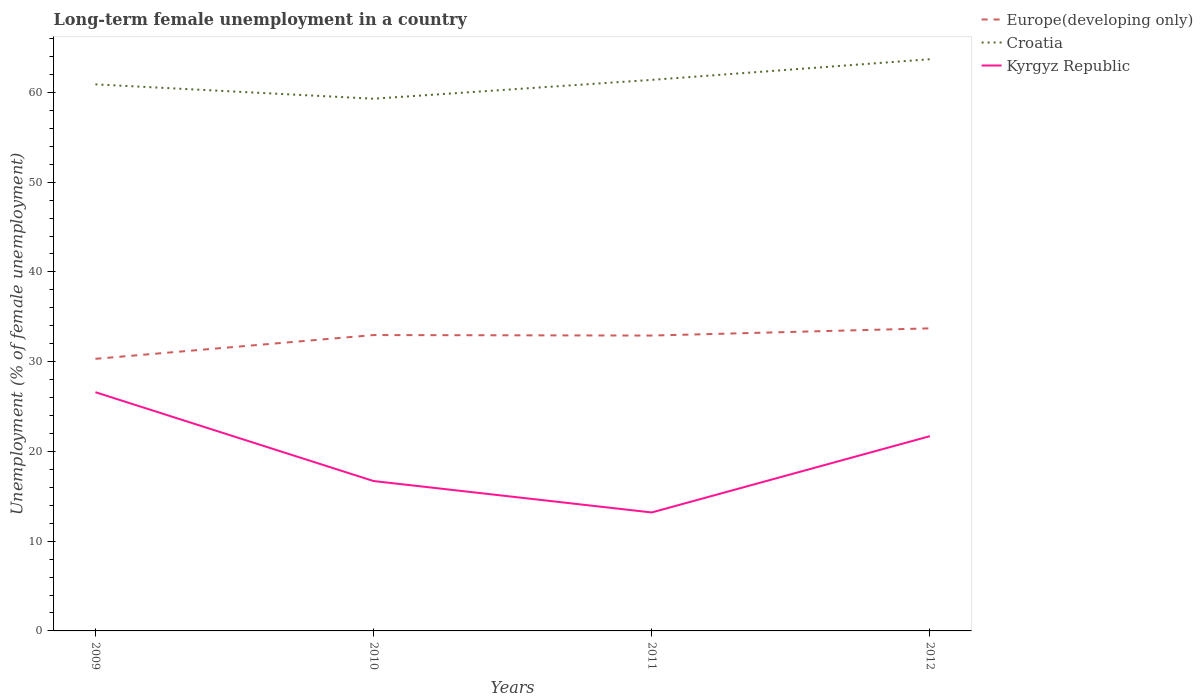Across all years, what is the maximum percentage of long-term unemployed female population in Croatia?
Your answer should be compact. 59.3. In which year was the percentage of long-term unemployed female population in Croatia maximum?
Your answer should be compact. 2010. What is the total percentage of long-term unemployed female population in Croatia in the graph?
Your answer should be compact. -2.3. What is the difference between the highest and the second highest percentage of long-term unemployed female population in Croatia?
Keep it short and to the point. 4.4. How many lines are there?
Ensure brevity in your answer.  3. How many years are there in the graph?
Make the answer very short. 4. What is the difference between two consecutive major ticks on the Y-axis?
Offer a terse response. 10. Are the values on the major ticks of Y-axis written in scientific E-notation?
Provide a short and direct response. No. Does the graph contain any zero values?
Offer a terse response. No. Does the graph contain grids?
Provide a succinct answer. No. What is the title of the graph?
Your response must be concise. Long-term female unemployment in a country. Does "Georgia" appear as one of the legend labels in the graph?
Provide a succinct answer. No. What is the label or title of the Y-axis?
Provide a short and direct response. Unemployment (% of female unemployment). What is the Unemployment (% of female unemployment) of Europe(developing only) in 2009?
Offer a very short reply. 30.32. What is the Unemployment (% of female unemployment) of Croatia in 2009?
Offer a terse response. 60.9. What is the Unemployment (% of female unemployment) in Kyrgyz Republic in 2009?
Offer a terse response. 26.6. What is the Unemployment (% of female unemployment) in Europe(developing only) in 2010?
Offer a terse response. 32.97. What is the Unemployment (% of female unemployment) of Croatia in 2010?
Keep it short and to the point. 59.3. What is the Unemployment (% of female unemployment) in Kyrgyz Republic in 2010?
Make the answer very short. 16.7. What is the Unemployment (% of female unemployment) of Europe(developing only) in 2011?
Offer a terse response. 32.91. What is the Unemployment (% of female unemployment) in Croatia in 2011?
Ensure brevity in your answer.  61.4. What is the Unemployment (% of female unemployment) of Kyrgyz Republic in 2011?
Keep it short and to the point. 13.2. What is the Unemployment (% of female unemployment) in Europe(developing only) in 2012?
Your response must be concise. 33.71. What is the Unemployment (% of female unemployment) of Croatia in 2012?
Provide a succinct answer. 63.7. What is the Unemployment (% of female unemployment) of Kyrgyz Republic in 2012?
Give a very brief answer. 21.7. Across all years, what is the maximum Unemployment (% of female unemployment) in Europe(developing only)?
Your response must be concise. 33.71. Across all years, what is the maximum Unemployment (% of female unemployment) of Croatia?
Your answer should be very brief. 63.7. Across all years, what is the maximum Unemployment (% of female unemployment) of Kyrgyz Republic?
Your response must be concise. 26.6. Across all years, what is the minimum Unemployment (% of female unemployment) of Europe(developing only)?
Your response must be concise. 30.32. Across all years, what is the minimum Unemployment (% of female unemployment) of Croatia?
Offer a very short reply. 59.3. Across all years, what is the minimum Unemployment (% of female unemployment) in Kyrgyz Republic?
Provide a succinct answer. 13.2. What is the total Unemployment (% of female unemployment) of Europe(developing only) in the graph?
Ensure brevity in your answer.  129.91. What is the total Unemployment (% of female unemployment) in Croatia in the graph?
Ensure brevity in your answer.  245.3. What is the total Unemployment (% of female unemployment) of Kyrgyz Republic in the graph?
Provide a short and direct response. 78.2. What is the difference between the Unemployment (% of female unemployment) in Europe(developing only) in 2009 and that in 2010?
Make the answer very short. -2.65. What is the difference between the Unemployment (% of female unemployment) in Croatia in 2009 and that in 2010?
Give a very brief answer. 1.6. What is the difference between the Unemployment (% of female unemployment) in Europe(developing only) in 2009 and that in 2011?
Provide a short and direct response. -2.59. What is the difference between the Unemployment (% of female unemployment) of Croatia in 2009 and that in 2011?
Your answer should be compact. -0.5. What is the difference between the Unemployment (% of female unemployment) in Europe(developing only) in 2009 and that in 2012?
Ensure brevity in your answer.  -3.4. What is the difference between the Unemployment (% of female unemployment) of Croatia in 2009 and that in 2012?
Offer a very short reply. -2.8. What is the difference between the Unemployment (% of female unemployment) in Kyrgyz Republic in 2009 and that in 2012?
Your response must be concise. 4.9. What is the difference between the Unemployment (% of female unemployment) of Europe(developing only) in 2010 and that in 2011?
Provide a short and direct response. 0.06. What is the difference between the Unemployment (% of female unemployment) of Kyrgyz Republic in 2010 and that in 2011?
Provide a short and direct response. 3.5. What is the difference between the Unemployment (% of female unemployment) in Europe(developing only) in 2010 and that in 2012?
Offer a terse response. -0.75. What is the difference between the Unemployment (% of female unemployment) in Croatia in 2010 and that in 2012?
Your response must be concise. -4.4. What is the difference between the Unemployment (% of female unemployment) of Kyrgyz Republic in 2010 and that in 2012?
Provide a short and direct response. -5. What is the difference between the Unemployment (% of female unemployment) of Europe(developing only) in 2011 and that in 2012?
Provide a succinct answer. -0.8. What is the difference between the Unemployment (% of female unemployment) of Kyrgyz Republic in 2011 and that in 2012?
Your answer should be very brief. -8.5. What is the difference between the Unemployment (% of female unemployment) of Europe(developing only) in 2009 and the Unemployment (% of female unemployment) of Croatia in 2010?
Provide a succinct answer. -28.98. What is the difference between the Unemployment (% of female unemployment) of Europe(developing only) in 2009 and the Unemployment (% of female unemployment) of Kyrgyz Republic in 2010?
Make the answer very short. 13.62. What is the difference between the Unemployment (% of female unemployment) in Croatia in 2009 and the Unemployment (% of female unemployment) in Kyrgyz Republic in 2010?
Keep it short and to the point. 44.2. What is the difference between the Unemployment (% of female unemployment) of Europe(developing only) in 2009 and the Unemployment (% of female unemployment) of Croatia in 2011?
Provide a short and direct response. -31.08. What is the difference between the Unemployment (% of female unemployment) in Europe(developing only) in 2009 and the Unemployment (% of female unemployment) in Kyrgyz Republic in 2011?
Your response must be concise. 17.12. What is the difference between the Unemployment (% of female unemployment) in Croatia in 2009 and the Unemployment (% of female unemployment) in Kyrgyz Republic in 2011?
Your answer should be very brief. 47.7. What is the difference between the Unemployment (% of female unemployment) in Europe(developing only) in 2009 and the Unemployment (% of female unemployment) in Croatia in 2012?
Your response must be concise. -33.38. What is the difference between the Unemployment (% of female unemployment) of Europe(developing only) in 2009 and the Unemployment (% of female unemployment) of Kyrgyz Republic in 2012?
Provide a succinct answer. 8.62. What is the difference between the Unemployment (% of female unemployment) of Croatia in 2009 and the Unemployment (% of female unemployment) of Kyrgyz Republic in 2012?
Your answer should be very brief. 39.2. What is the difference between the Unemployment (% of female unemployment) in Europe(developing only) in 2010 and the Unemployment (% of female unemployment) in Croatia in 2011?
Provide a succinct answer. -28.43. What is the difference between the Unemployment (% of female unemployment) in Europe(developing only) in 2010 and the Unemployment (% of female unemployment) in Kyrgyz Republic in 2011?
Your response must be concise. 19.77. What is the difference between the Unemployment (% of female unemployment) in Croatia in 2010 and the Unemployment (% of female unemployment) in Kyrgyz Republic in 2011?
Your response must be concise. 46.1. What is the difference between the Unemployment (% of female unemployment) of Europe(developing only) in 2010 and the Unemployment (% of female unemployment) of Croatia in 2012?
Your answer should be compact. -30.73. What is the difference between the Unemployment (% of female unemployment) in Europe(developing only) in 2010 and the Unemployment (% of female unemployment) in Kyrgyz Republic in 2012?
Ensure brevity in your answer.  11.27. What is the difference between the Unemployment (% of female unemployment) of Croatia in 2010 and the Unemployment (% of female unemployment) of Kyrgyz Republic in 2012?
Keep it short and to the point. 37.6. What is the difference between the Unemployment (% of female unemployment) in Europe(developing only) in 2011 and the Unemployment (% of female unemployment) in Croatia in 2012?
Offer a very short reply. -30.79. What is the difference between the Unemployment (% of female unemployment) in Europe(developing only) in 2011 and the Unemployment (% of female unemployment) in Kyrgyz Republic in 2012?
Make the answer very short. 11.21. What is the difference between the Unemployment (% of female unemployment) of Croatia in 2011 and the Unemployment (% of female unemployment) of Kyrgyz Republic in 2012?
Offer a very short reply. 39.7. What is the average Unemployment (% of female unemployment) in Europe(developing only) per year?
Offer a very short reply. 32.48. What is the average Unemployment (% of female unemployment) of Croatia per year?
Offer a very short reply. 61.33. What is the average Unemployment (% of female unemployment) in Kyrgyz Republic per year?
Offer a very short reply. 19.55. In the year 2009, what is the difference between the Unemployment (% of female unemployment) of Europe(developing only) and Unemployment (% of female unemployment) of Croatia?
Ensure brevity in your answer.  -30.58. In the year 2009, what is the difference between the Unemployment (% of female unemployment) of Europe(developing only) and Unemployment (% of female unemployment) of Kyrgyz Republic?
Give a very brief answer. 3.72. In the year 2009, what is the difference between the Unemployment (% of female unemployment) in Croatia and Unemployment (% of female unemployment) in Kyrgyz Republic?
Provide a succinct answer. 34.3. In the year 2010, what is the difference between the Unemployment (% of female unemployment) in Europe(developing only) and Unemployment (% of female unemployment) in Croatia?
Offer a very short reply. -26.33. In the year 2010, what is the difference between the Unemployment (% of female unemployment) in Europe(developing only) and Unemployment (% of female unemployment) in Kyrgyz Republic?
Provide a succinct answer. 16.27. In the year 2010, what is the difference between the Unemployment (% of female unemployment) of Croatia and Unemployment (% of female unemployment) of Kyrgyz Republic?
Your answer should be very brief. 42.6. In the year 2011, what is the difference between the Unemployment (% of female unemployment) in Europe(developing only) and Unemployment (% of female unemployment) in Croatia?
Ensure brevity in your answer.  -28.49. In the year 2011, what is the difference between the Unemployment (% of female unemployment) in Europe(developing only) and Unemployment (% of female unemployment) in Kyrgyz Republic?
Make the answer very short. 19.71. In the year 2011, what is the difference between the Unemployment (% of female unemployment) of Croatia and Unemployment (% of female unemployment) of Kyrgyz Republic?
Give a very brief answer. 48.2. In the year 2012, what is the difference between the Unemployment (% of female unemployment) in Europe(developing only) and Unemployment (% of female unemployment) in Croatia?
Ensure brevity in your answer.  -29.99. In the year 2012, what is the difference between the Unemployment (% of female unemployment) of Europe(developing only) and Unemployment (% of female unemployment) of Kyrgyz Republic?
Offer a terse response. 12.01. In the year 2012, what is the difference between the Unemployment (% of female unemployment) in Croatia and Unemployment (% of female unemployment) in Kyrgyz Republic?
Your response must be concise. 42. What is the ratio of the Unemployment (% of female unemployment) in Europe(developing only) in 2009 to that in 2010?
Provide a short and direct response. 0.92. What is the ratio of the Unemployment (% of female unemployment) in Croatia in 2009 to that in 2010?
Your response must be concise. 1.03. What is the ratio of the Unemployment (% of female unemployment) of Kyrgyz Republic in 2009 to that in 2010?
Your answer should be very brief. 1.59. What is the ratio of the Unemployment (% of female unemployment) of Europe(developing only) in 2009 to that in 2011?
Keep it short and to the point. 0.92. What is the ratio of the Unemployment (% of female unemployment) in Kyrgyz Republic in 2009 to that in 2011?
Offer a terse response. 2.02. What is the ratio of the Unemployment (% of female unemployment) in Europe(developing only) in 2009 to that in 2012?
Keep it short and to the point. 0.9. What is the ratio of the Unemployment (% of female unemployment) in Croatia in 2009 to that in 2012?
Your answer should be compact. 0.96. What is the ratio of the Unemployment (% of female unemployment) in Kyrgyz Republic in 2009 to that in 2012?
Give a very brief answer. 1.23. What is the ratio of the Unemployment (% of female unemployment) of Europe(developing only) in 2010 to that in 2011?
Your answer should be compact. 1. What is the ratio of the Unemployment (% of female unemployment) in Croatia in 2010 to that in 2011?
Make the answer very short. 0.97. What is the ratio of the Unemployment (% of female unemployment) of Kyrgyz Republic in 2010 to that in 2011?
Your answer should be very brief. 1.27. What is the ratio of the Unemployment (% of female unemployment) in Europe(developing only) in 2010 to that in 2012?
Offer a terse response. 0.98. What is the ratio of the Unemployment (% of female unemployment) of Croatia in 2010 to that in 2012?
Your answer should be very brief. 0.93. What is the ratio of the Unemployment (% of female unemployment) of Kyrgyz Republic in 2010 to that in 2012?
Your response must be concise. 0.77. What is the ratio of the Unemployment (% of female unemployment) in Europe(developing only) in 2011 to that in 2012?
Your answer should be very brief. 0.98. What is the ratio of the Unemployment (% of female unemployment) in Croatia in 2011 to that in 2012?
Your answer should be compact. 0.96. What is the ratio of the Unemployment (% of female unemployment) of Kyrgyz Republic in 2011 to that in 2012?
Give a very brief answer. 0.61. What is the difference between the highest and the second highest Unemployment (% of female unemployment) in Europe(developing only)?
Offer a terse response. 0.75. What is the difference between the highest and the lowest Unemployment (% of female unemployment) of Europe(developing only)?
Offer a terse response. 3.4. 